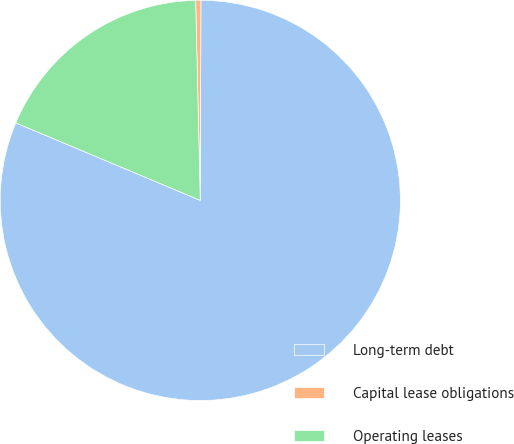<chart> <loc_0><loc_0><loc_500><loc_500><pie_chart><fcel>Long-term debt<fcel>Capital lease obligations<fcel>Operating leases<nl><fcel>81.28%<fcel>0.42%<fcel>18.3%<nl></chart> 